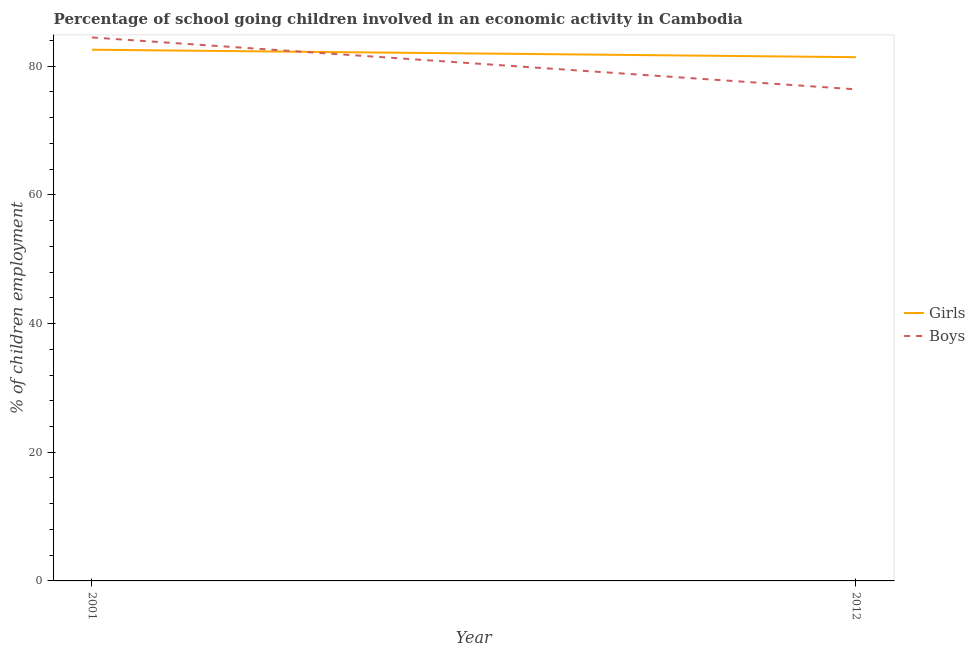Is the number of lines equal to the number of legend labels?
Your answer should be compact. Yes. What is the percentage of school going girls in 2001?
Your response must be concise. 82.56. Across all years, what is the maximum percentage of school going girls?
Give a very brief answer. 82.56. Across all years, what is the minimum percentage of school going girls?
Make the answer very short. 81.4. In which year was the percentage of school going girls minimum?
Ensure brevity in your answer.  2012. What is the total percentage of school going boys in the graph?
Keep it short and to the point. 160.86. What is the difference between the percentage of school going girls in 2001 and that in 2012?
Ensure brevity in your answer.  1.16. What is the difference between the percentage of school going girls in 2012 and the percentage of school going boys in 2001?
Offer a very short reply. -3.06. What is the average percentage of school going girls per year?
Keep it short and to the point. 81.98. In the year 2001, what is the difference between the percentage of school going girls and percentage of school going boys?
Keep it short and to the point. -1.91. What is the ratio of the percentage of school going boys in 2001 to that in 2012?
Offer a very short reply. 1.11. Does the percentage of school going girls monotonically increase over the years?
Offer a terse response. No. Is the percentage of school going boys strictly greater than the percentage of school going girls over the years?
Give a very brief answer. No. Is the percentage of school going girls strictly less than the percentage of school going boys over the years?
Provide a short and direct response. No. How many years are there in the graph?
Ensure brevity in your answer.  2. Are the values on the major ticks of Y-axis written in scientific E-notation?
Ensure brevity in your answer.  No. Does the graph contain any zero values?
Provide a succinct answer. No. How many legend labels are there?
Offer a terse response. 2. What is the title of the graph?
Keep it short and to the point. Percentage of school going children involved in an economic activity in Cambodia. What is the label or title of the X-axis?
Your response must be concise. Year. What is the label or title of the Y-axis?
Your answer should be compact. % of children employment. What is the % of children employment in Girls in 2001?
Offer a very short reply. 82.56. What is the % of children employment in Boys in 2001?
Provide a short and direct response. 84.46. What is the % of children employment in Girls in 2012?
Make the answer very short. 81.4. What is the % of children employment of Boys in 2012?
Make the answer very short. 76.4. Across all years, what is the maximum % of children employment in Girls?
Give a very brief answer. 82.56. Across all years, what is the maximum % of children employment of Boys?
Ensure brevity in your answer.  84.46. Across all years, what is the minimum % of children employment of Girls?
Your answer should be compact. 81.4. Across all years, what is the minimum % of children employment of Boys?
Your answer should be very brief. 76.4. What is the total % of children employment in Girls in the graph?
Give a very brief answer. 163.96. What is the total % of children employment in Boys in the graph?
Your answer should be compact. 160.86. What is the difference between the % of children employment of Girls in 2001 and that in 2012?
Your answer should be very brief. 1.16. What is the difference between the % of children employment of Boys in 2001 and that in 2012?
Your answer should be very brief. 8.06. What is the difference between the % of children employment in Girls in 2001 and the % of children employment in Boys in 2012?
Ensure brevity in your answer.  6.16. What is the average % of children employment in Girls per year?
Provide a succinct answer. 81.98. What is the average % of children employment of Boys per year?
Your answer should be very brief. 80.43. In the year 2001, what is the difference between the % of children employment of Girls and % of children employment of Boys?
Your response must be concise. -1.91. In the year 2012, what is the difference between the % of children employment of Girls and % of children employment of Boys?
Your answer should be very brief. 5. What is the ratio of the % of children employment of Girls in 2001 to that in 2012?
Your response must be concise. 1.01. What is the ratio of the % of children employment of Boys in 2001 to that in 2012?
Your answer should be very brief. 1.11. What is the difference between the highest and the second highest % of children employment of Girls?
Your response must be concise. 1.16. What is the difference between the highest and the second highest % of children employment of Boys?
Provide a short and direct response. 8.06. What is the difference between the highest and the lowest % of children employment in Girls?
Ensure brevity in your answer.  1.16. What is the difference between the highest and the lowest % of children employment of Boys?
Provide a succinct answer. 8.06. 